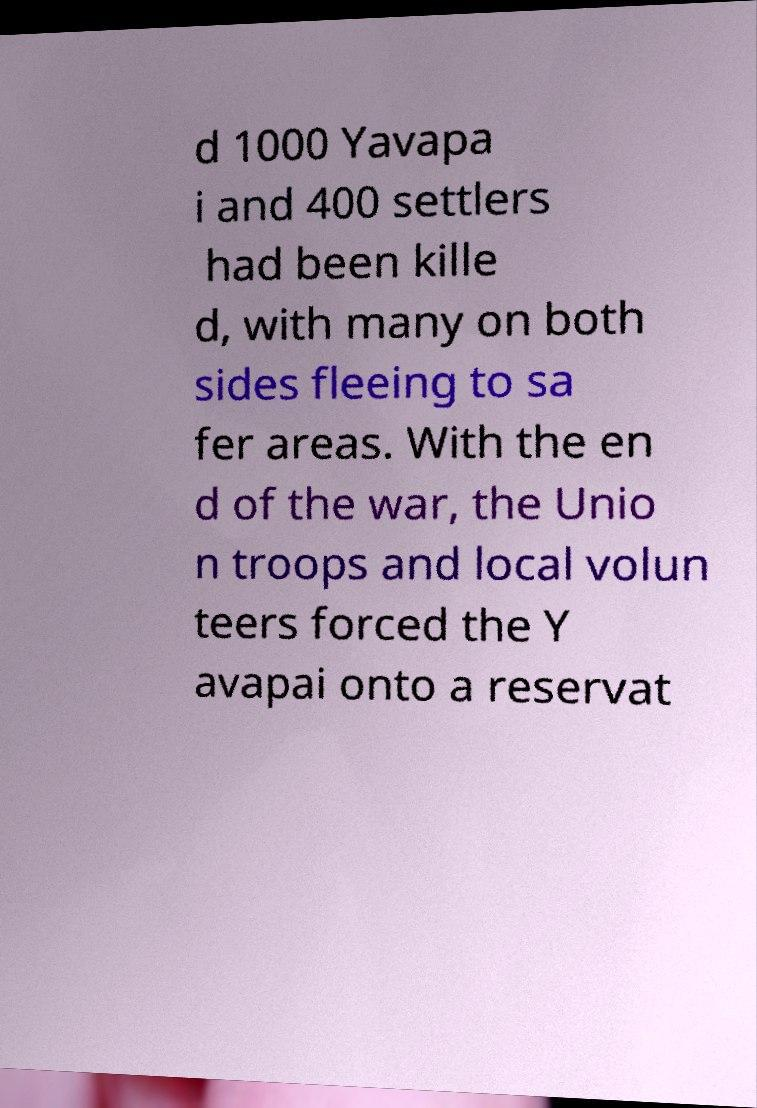Please read and relay the text visible in this image. What does it say? d 1000 Yavapa i and 400 settlers had been kille d, with many on both sides fleeing to sa fer areas. With the en d of the war, the Unio n troops and local volun teers forced the Y avapai onto a reservat 